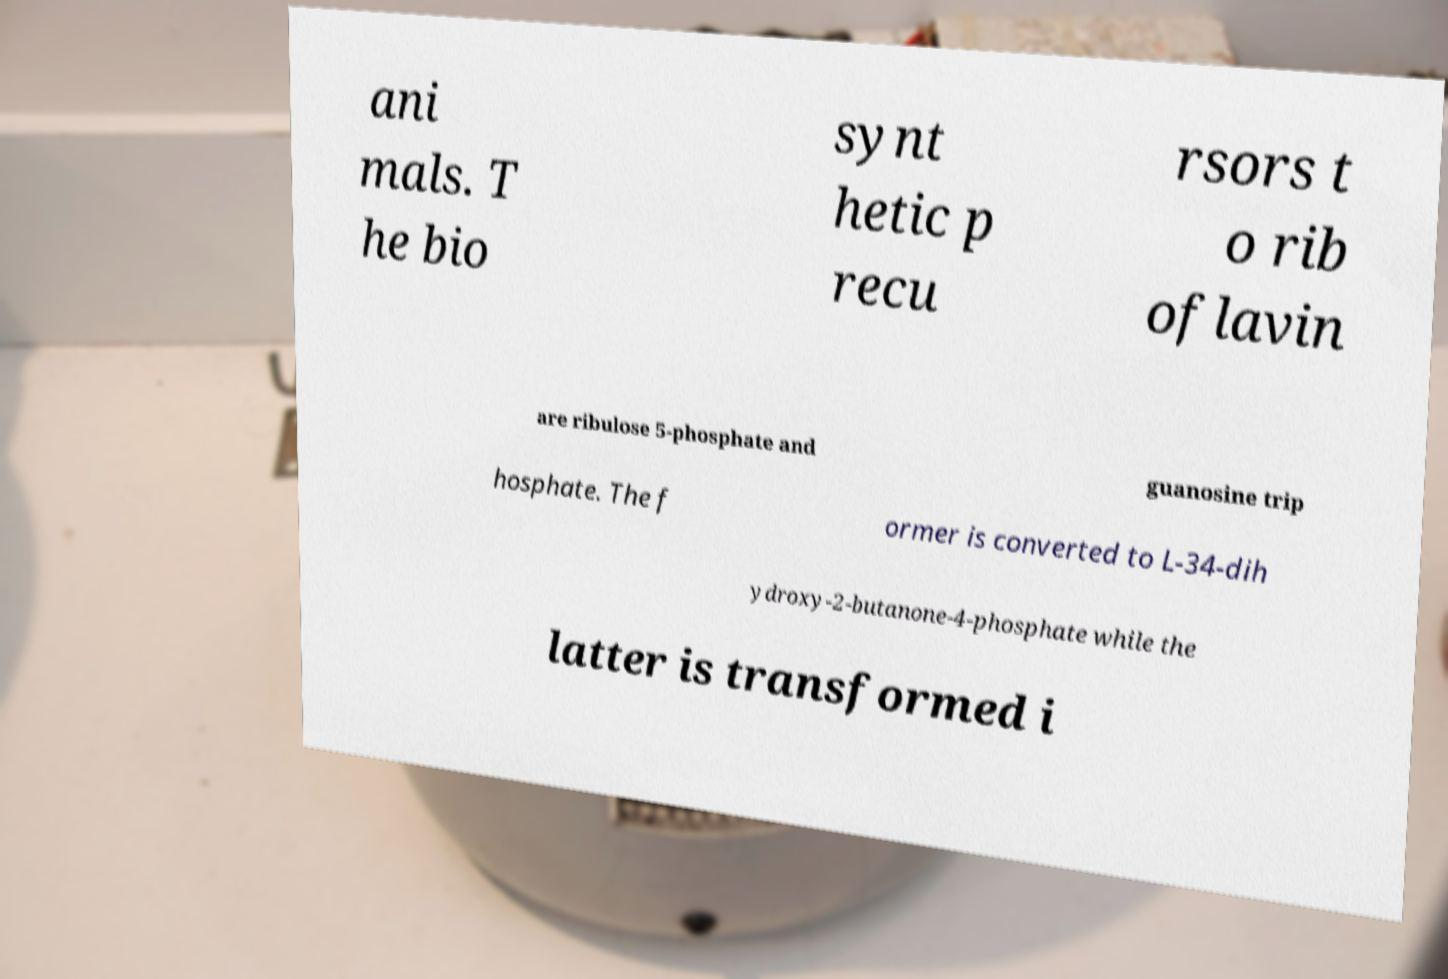Please identify and transcribe the text found in this image. ani mals. T he bio synt hetic p recu rsors t o rib oflavin are ribulose 5-phosphate and guanosine trip hosphate. The f ormer is converted to L-34-dih ydroxy-2-butanone-4-phosphate while the latter is transformed i 